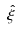Convert formula to latex. <formula><loc_0><loc_0><loc_500><loc_500>\hat { \xi }</formula> 